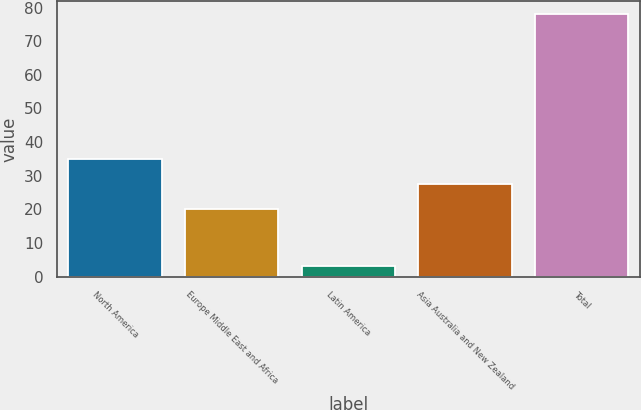<chart> <loc_0><loc_0><loc_500><loc_500><bar_chart><fcel>North America<fcel>Europe Middle East and Africa<fcel>Latin America<fcel>Asia Australia and New Zealand<fcel>Total<nl><fcel>35<fcel>20<fcel>3<fcel>27.5<fcel>78<nl></chart> 